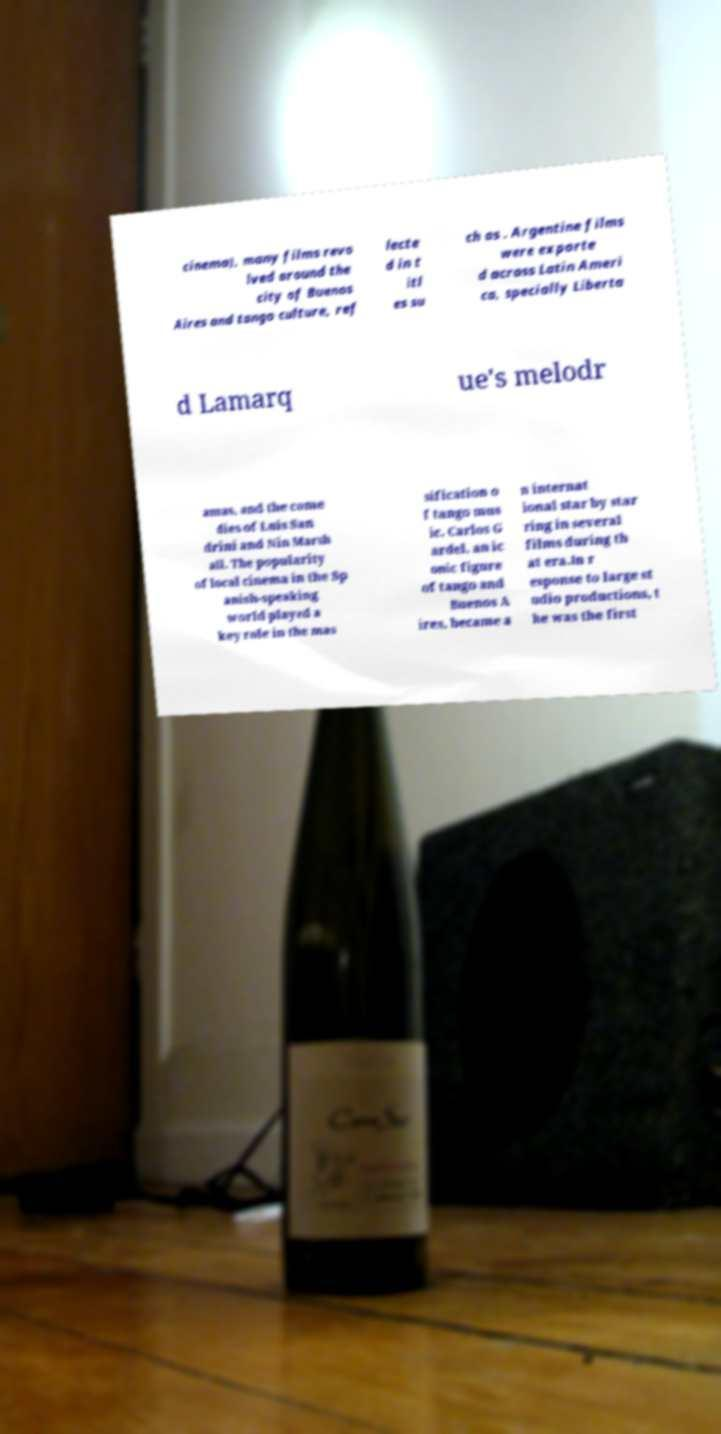Please read and relay the text visible in this image. What does it say? cinema), many films revo lved around the city of Buenos Aires and tango culture, ref lecte d in t itl es su ch as . Argentine films were exporte d across Latin Ameri ca, specially Liberta d Lamarq ue's melodr amas, and the come dies of Luis San drini and Nin Marsh all. The popularity of local cinema in the Sp anish-speaking world played a key role in the mas sification o f tango mus ic. Carlos G ardel, an ic onic figure of tango and Buenos A ires, became a n internat ional star by star ring in several films during th at era.In r esponse to large st udio productions, t he was the first 